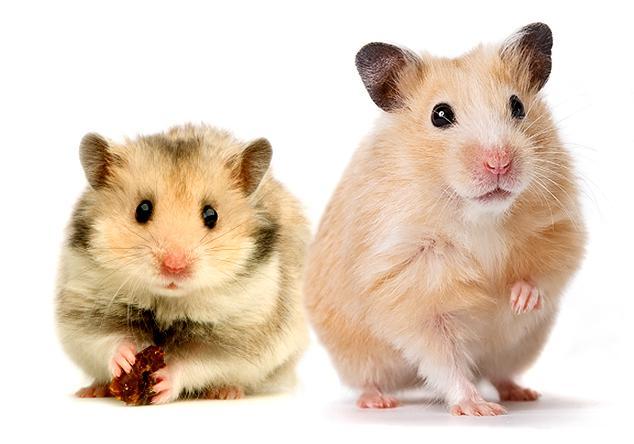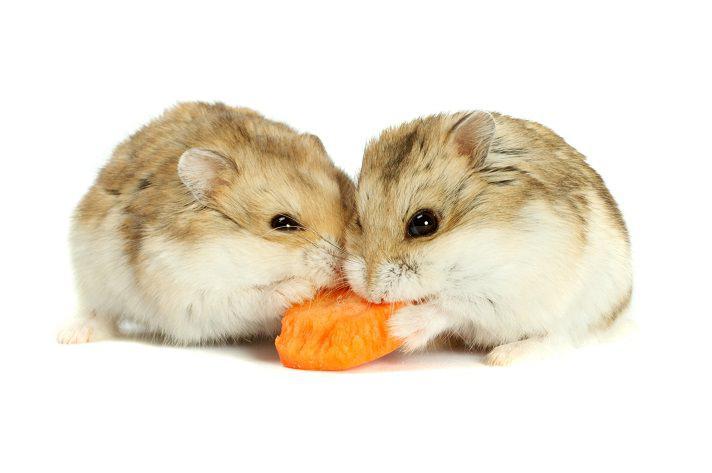The first image is the image on the left, the second image is the image on the right. Assess this claim about the two images: "The rodents in the image on the left are face to face.". Correct or not? Answer yes or no. No. The first image is the image on the left, the second image is the image on the right. For the images shown, is this caption "Each image contains two pet rodents, and at least one image includes a rodent sitting upright." true? Answer yes or no. Yes. 